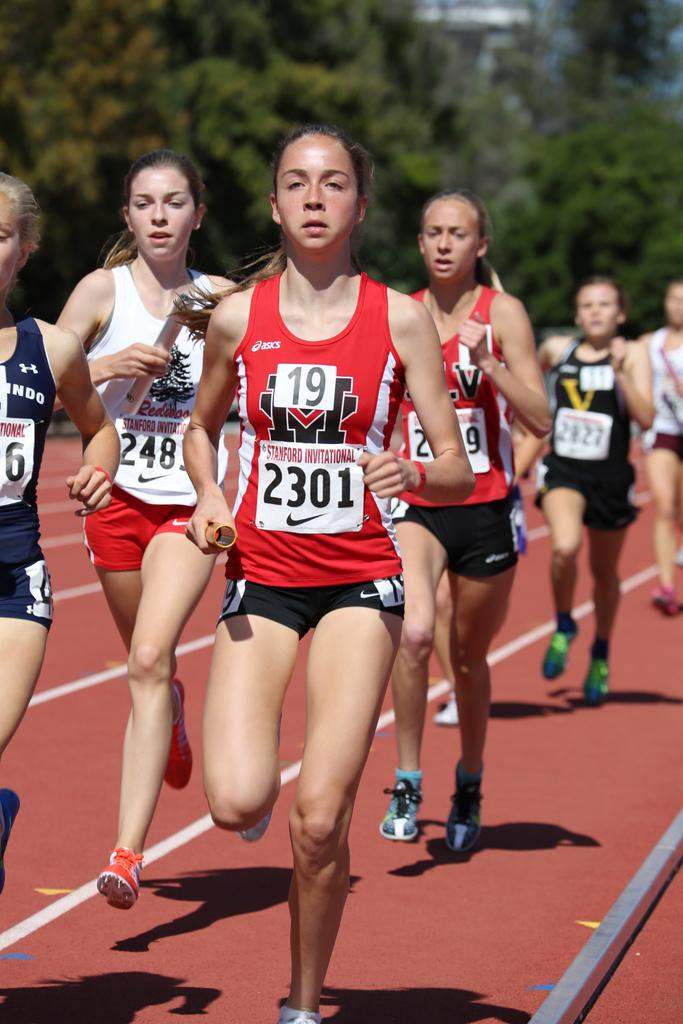<image>
Describe the image concisely. Several runners dressed in black and red has 2301 written on number 19 jersey. 